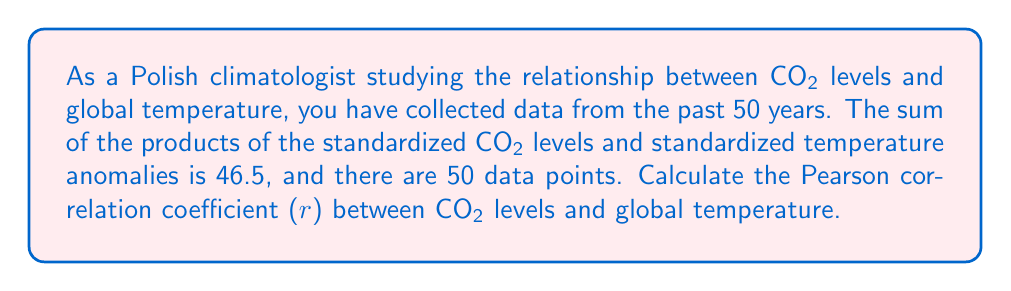Help me with this question. To calculate the Pearson correlation coefficient (r), we can use the formula:

$$ r = \frac{\sum_{i=1}^{n} z_x z_y}{n - 1} $$

Where:
- $z_x$ and $z_y$ are the standardized values for each variable
- $n$ is the number of data points

We are given:
- $\sum_{i=1}^{n} z_x z_y = 46.5$
- $n = 50$

Substituting these values into the formula:

$$ r = \frac{46.5}{50 - 1} $$

$$ r = \frac{46.5}{49} $$

$$ r \approx 0.9490 $$

This value indicates a strong positive correlation between CO2 levels and global temperature, which is consistent with the scientific consensus on climate change.
Answer: $r \approx 0.9490$ 